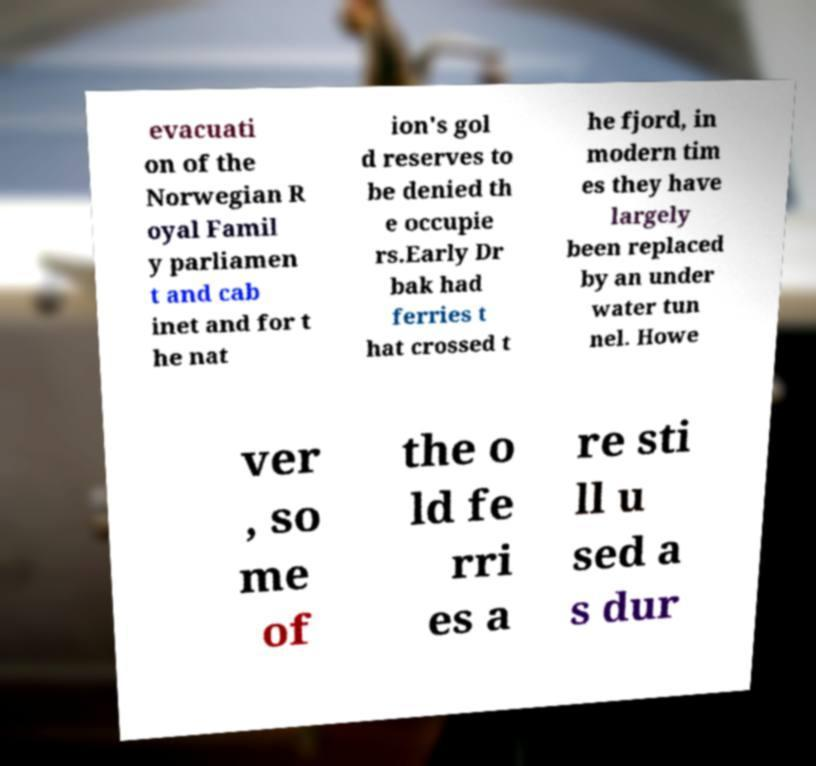Could you extract and type out the text from this image? evacuati on of the Norwegian R oyal Famil y parliamen t and cab inet and for t he nat ion's gol d reserves to be denied th e occupie rs.Early Dr bak had ferries t hat crossed t he fjord, in modern tim es they have largely been replaced by an under water tun nel. Howe ver , so me of the o ld fe rri es a re sti ll u sed a s dur 